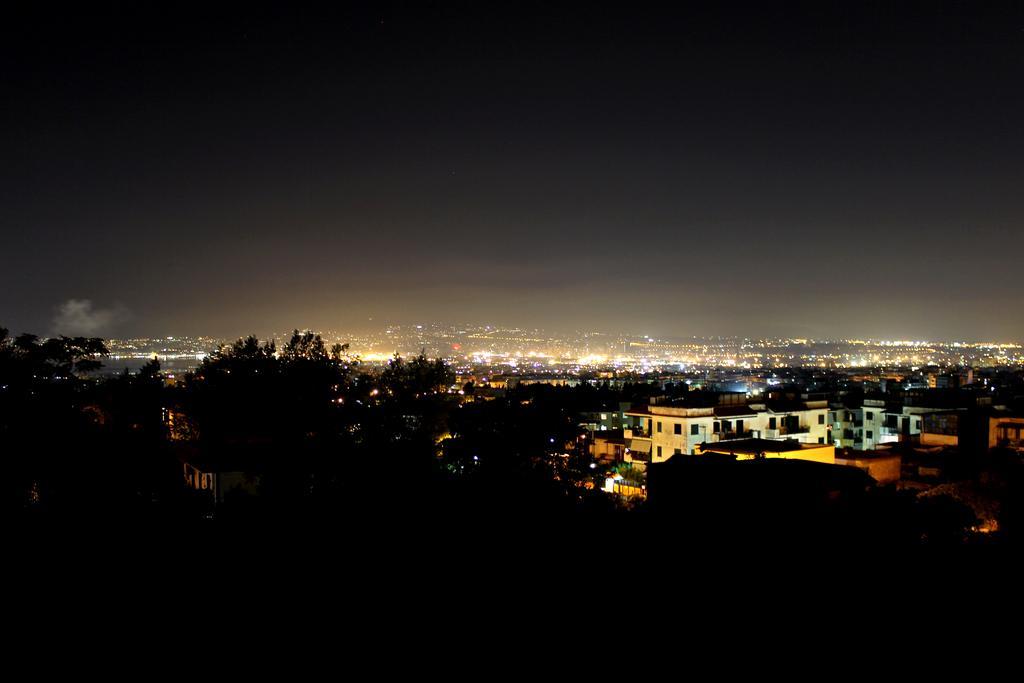Can you describe this image briefly? In this image in the background there are trees, buildings, lights. The sky is clear. The foreground is dark. 